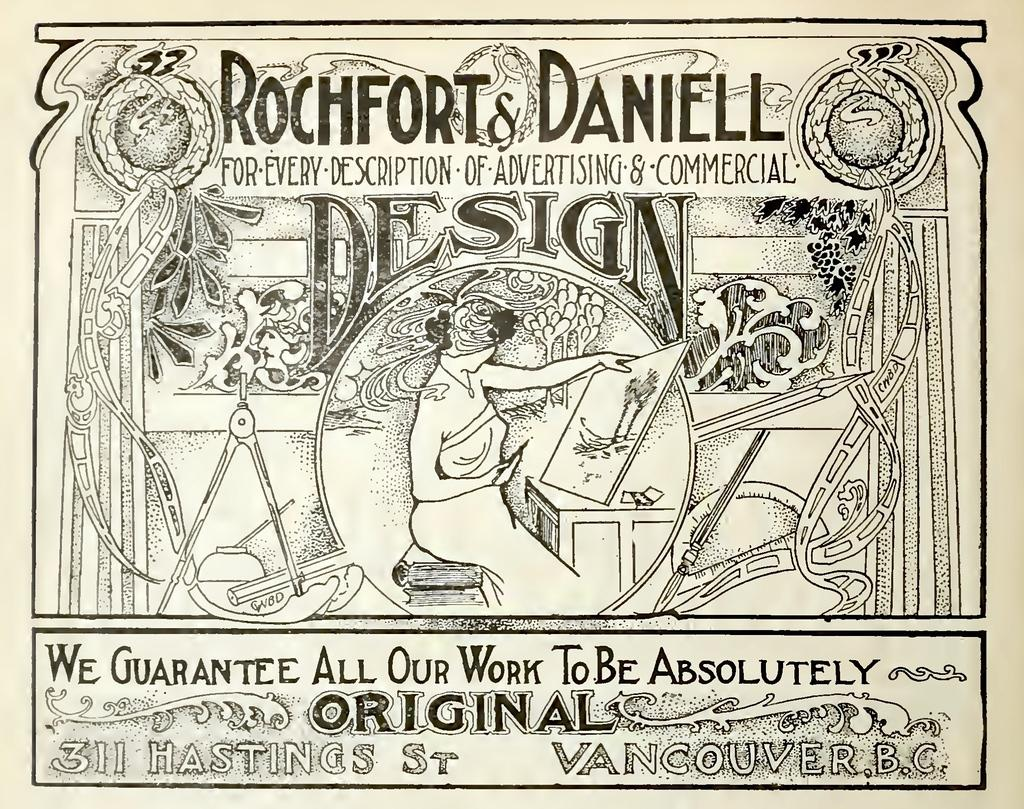What is present in the image that contains both images and text? There is a poster in the image that contains images and text. What type of arch can be seen in the poster in the image? There is no arch present in the poster or the image. 